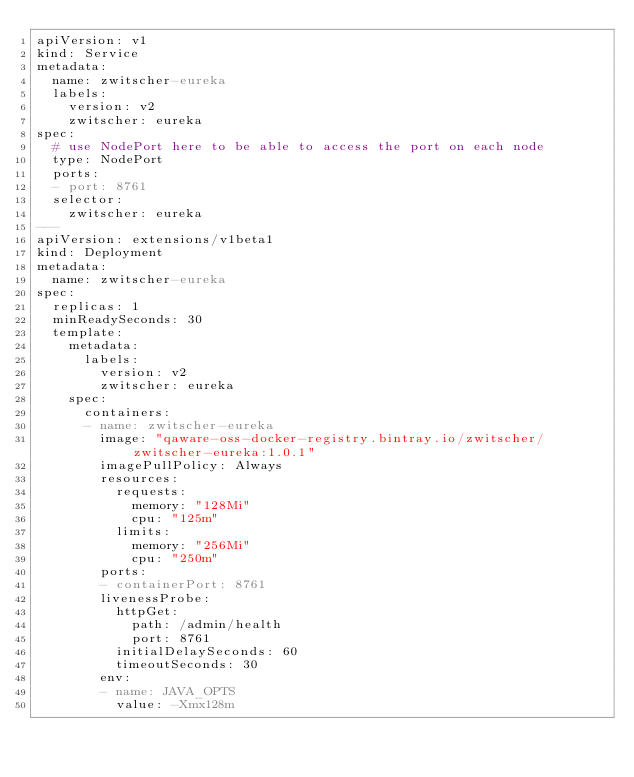Convert code to text. <code><loc_0><loc_0><loc_500><loc_500><_YAML_>apiVersion: v1
kind: Service
metadata:
  name: zwitscher-eureka
  labels:
    version: v2
    zwitscher: eureka
spec:
  # use NodePort here to be able to access the port on each node
  type: NodePort
  ports:
  - port: 8761
  selector:
    zwitscher: eureka
---
apiVersion: extensions/v1beta1
kind: Deployment
metadata:
  name: zwitscher-eureka
spec:
  replicas: 1
  minReadySeconds: 30
  template:
    metadata:
      labels:
        version: v2
        zwitscher: eureka
    spec:
      containers:
      - name: zwitscher-eureka
        image: "qaware-oss-docker-registry.bintray.io/zwitscher/zwitscher-eureka:1.0.1"
        imagePullPolicy: Always
        resources:
          requests:
            memory: "128Mi"
            cpu: "125m"
          limits:
            memory: "256Mi"
            cpu: "250m"
        ports:
        - containerPort: 8761
        livenessProbe:
          httpGet:
            path: /admin/health
            port: 8761
          initialDelaySeconds: 60
          timeoutSeconds: 30
        env:
        - name: JAVA_OPTS
          value: -Xmx128m</code> 